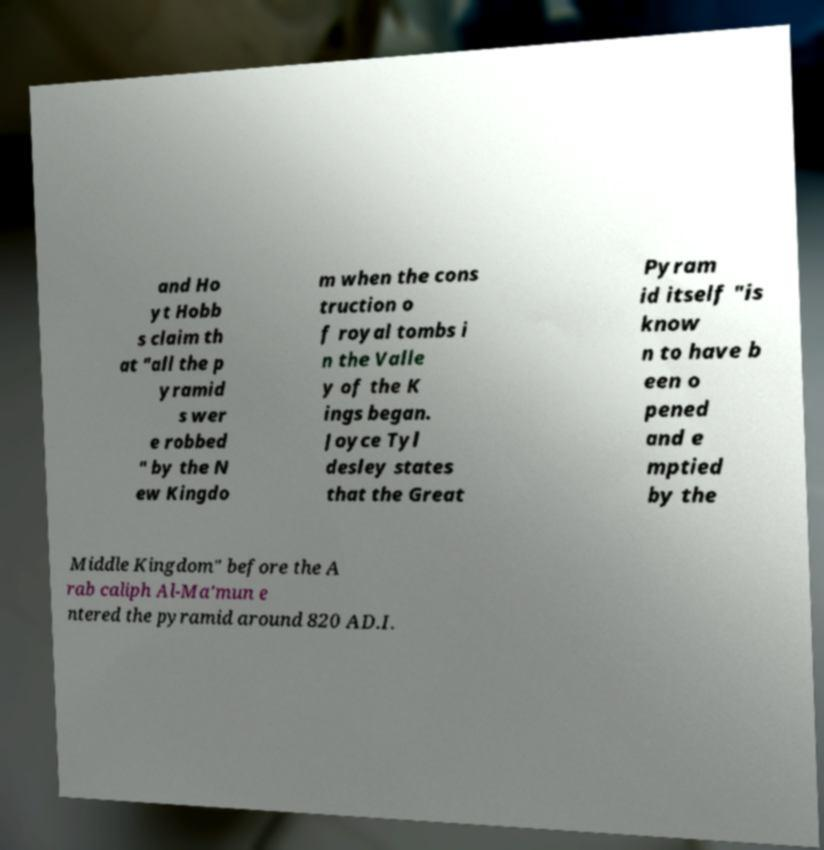There's text embedded in this image that I need extracted. Can you transcribe it verbatim? and Ho yt Hobb s claim th at "all the p yramid s wer e robbed " by the N ew Kingdo m when the cons truction o f royal tombs i n the Valle y of the K ings began. Joyce Tyl desley states that the Great Pyram id itself "is know n to have b een o pened and e mptied by the Middle Kingdom" before the A rab caliph Al-Ma'mun e ntered the pyramid around 820 AD.I. 